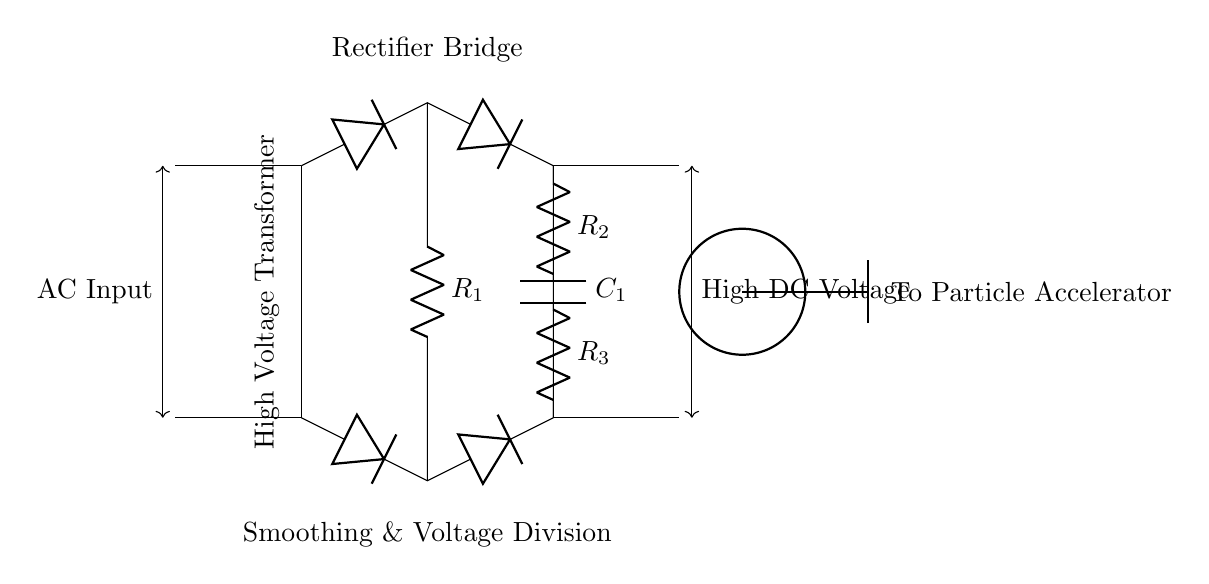What is the primary function of the high voltage transformer in this circuit? The primary function of the high voltage transformer is to step up the incoming AC voltage to a higher level suitable for operation with the particle accelerator.
Answer: Step up voltage What components are used in the rectifier bridge? The components used in the rectifier bridge are four diodes that are arranged to allow current to flow in one direction, converting AC to DC.
Answer: Four diodes What is the purpose of the smoothing capacitor in this circuit? The purpose of the smoothing capacitor is to reduce the ripple in the output DC voltage by storing and releasing charge, providing a more stable voltage.
Answer: Reduce ripple How do the resistors R2 and R3 function together in the circuit? Resistors R2 and R3 function as a voltage divider, allowing for the regulation of the voltage output to the particle accelerator by sharing the total voltage across them.
Answer: Voltage divider What is the output type of this circuit? The output type of this circuit is high direct current voltage, which is necessary for the functioning of the particle accelerator.
Answer: High DC voltage What type of power supply is simulated by this circuit? This circuit simulates a high-voltage direct current power supply that is specifically designed for high power applications like particle accelerators.
Answer: High-voltage DC power supply 